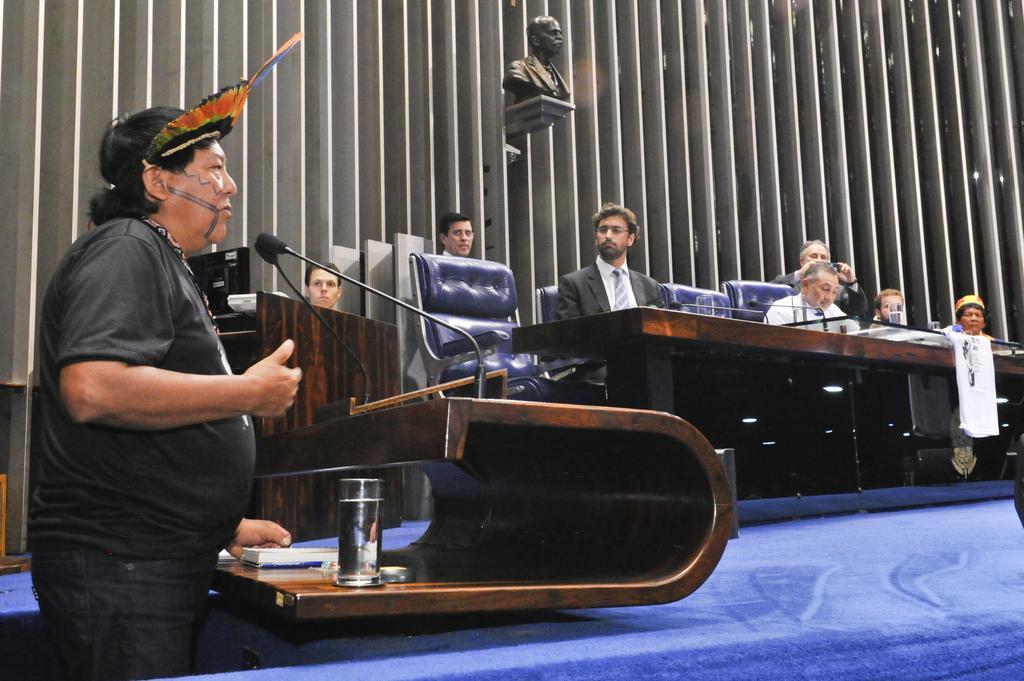Could you give a brief overview of what you see in this image? In this image we can see a man standing at the podium on the left side. We can see many people sitting on the chairs. There is a statue on the wall. 